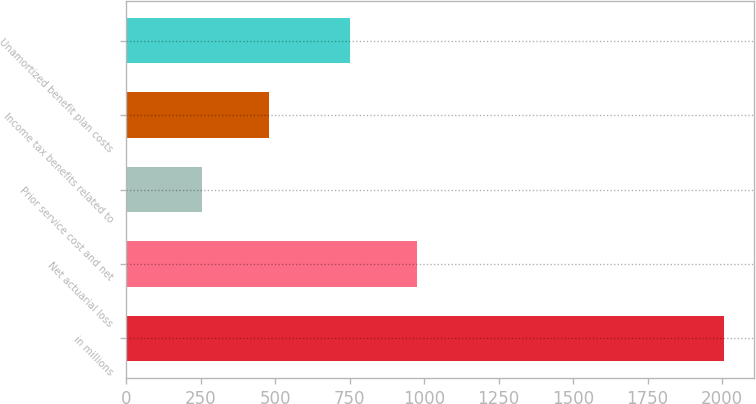Convert chart. <chart><loc_0><loc_0><loc_500><loc_500><bar_chart><fcel>in millions<fcel>Net actuarial loss<fcel>Prior service cost and net<fcel>Income tax benefits related to<fcel>Unamortized benefit plan costs<nl><fcel>2007<fcel>975<fcel>254<fcel>479<fcel>750<nl></chart> 